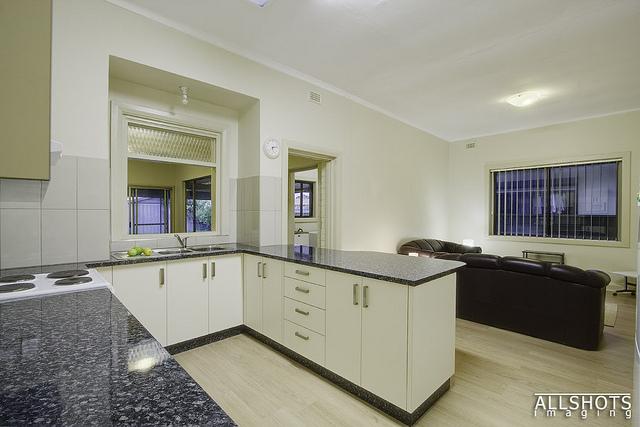How many drawers are open?
Keep it brief. 0. Is the floor clean?
Write a very short answer. Yes. What color are the cabinets?
Give a very brief answer. White. What color is the clock in the picture?
Quick response, please. White. Is there a paper towel roll on the counter?
Give a very brief answer. No. What time is on the clock?
Keep it brief. 5:15. What color are the kitchen cabinets?
Be succinct. White. Is this a bedroom?
Be succinct. No. 